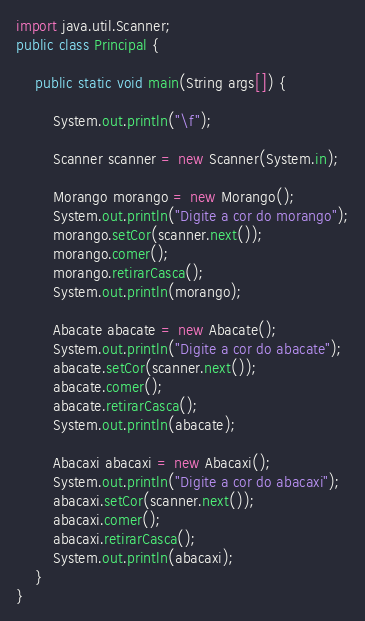<code> <loc_0><loc_0><loc_500><loc_500><_Java_>import java.util.Scanner;
public class Principal {
    
    public static void main(String args[]) {
        
        System.out.println("\f");
        
        Scanner scanner = new Scanner(System.in);
        
        Morango morango = new Morango();
        System.out.println("Digite a cor do morango");
        morango.setCor(scanner.next());
        morango.comer();
        morango.retirarCasca();
        System.out.println(morango);
        
        Abacate abacate = new Abacate();
        System.out.println("Digite a cor do abacate");
        abacate.setCor(scanner.next());
        abacate.comer();
        abacate.retirarCasca();
        System.out.println(abacate);
        
        Abacaxi abacaxi = new Abacaxi();
        System.out.println("Digite a cor do abacaxi");
        abacaxi.setCor(scanner.next());
        abacaxi.comer();
        abacaxi.retirarCasca();
        System.out.println(abacaxi);
    }
}</code> 